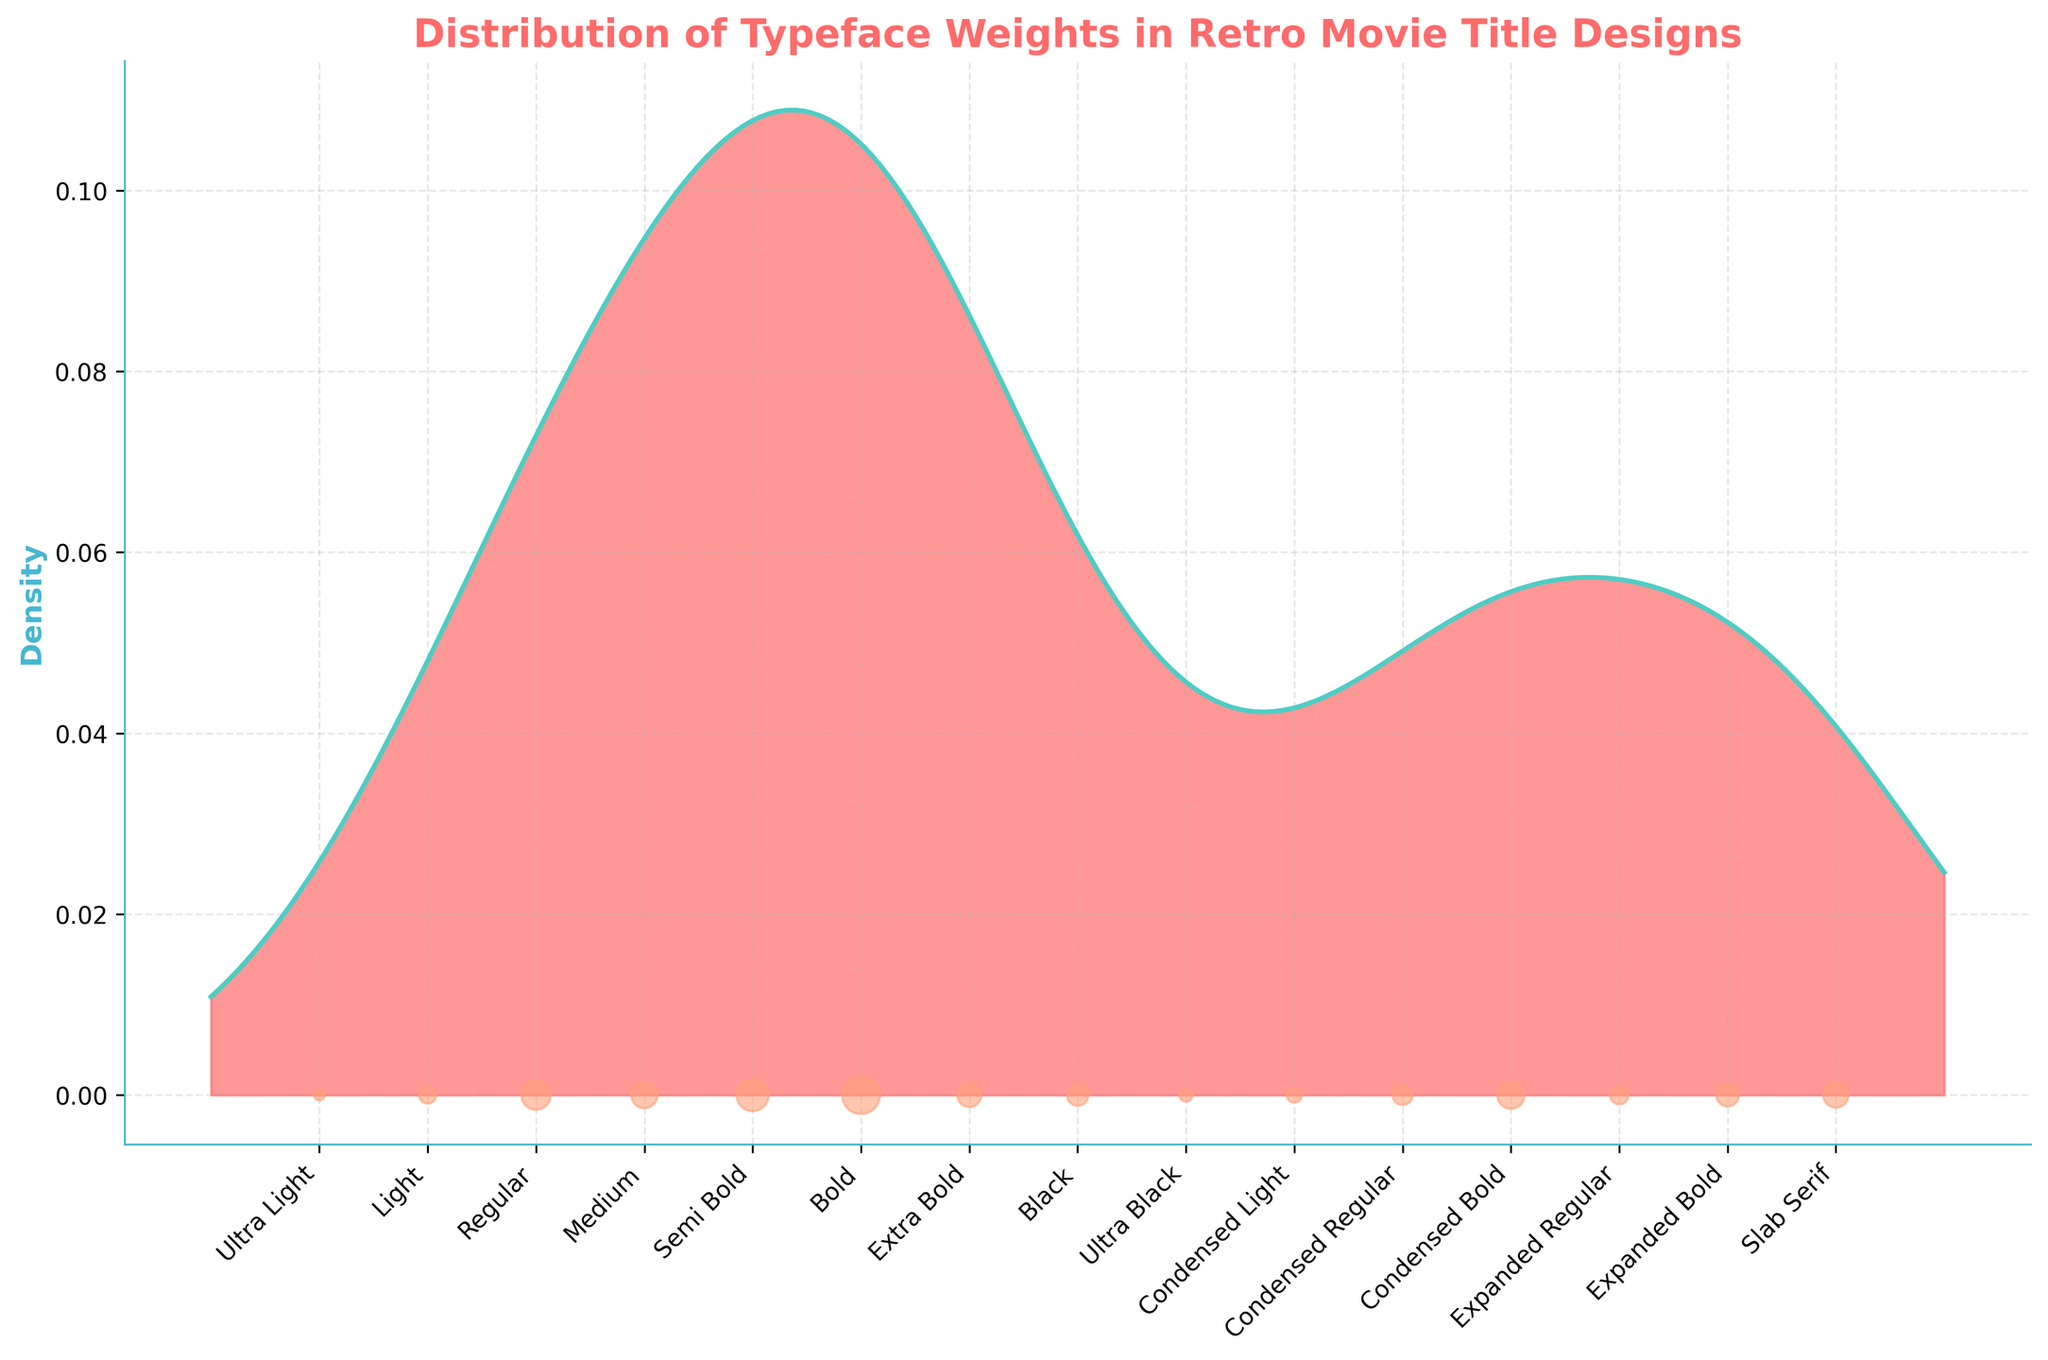What is the title of the plot? The title is typically displayed at the top of the plot. In this case, the title reads "Distribution of Typeface Weights in Retro Movie Title Designs".
Answer: Distribution of Typeface Weights in Retro Movie Title Designs What is the color of the density fill? The fill color of the density plot can be observed directly from the figure. It is a pinkish-red hue.
Answer: Pinkish-red Which typeface weight has the highest frequency? To determine the highest frequency, you will look for the tallest point in the scatter plot. The data point with the largest marker is associated with "Bold".
Answer: Bold How many typeface weights are represented? Count the number of x-tick labels along the x-axis to determine the total number of typeface weights. The figure shows 15 different typeface weights.
Answer: 15 What can you say about the distribution of typeface weights in terms of density? From the density plot, observe that the density curve peaks at the "Bold" typeface weight, suggesting most retro movie titles use a bolder weight more frequently. The density then tapers off on either side.
Answer: Most titles use "Bold" weight frequently Which typeface weights show some degree of condensation? The x-tick labels for condensed weights are named explicitly with "Condensed". By looking at the labels, "Condensed Light," "Condensed Regular," and "Condensed Bold" are these weights.
Answer: Condensed Light, Condensed Regular, Condensed Bold How does the density of "Medium" compare to "Regular"? To compare densities, observe the height of the density curve values directly above "Medium" and "Regular". "Regular" has a slightly higher density compared to "Medium".
Answer: Regular is higher than Medium Which two typeface weights contribute the least to the density plot? The least contributing typefaces will be those with the smallest frequencies, evident from the height of the smallest scatter points. These are "Ultra Light" and "Ultra Black".
Answer: Ultra Light, Ultra Black 